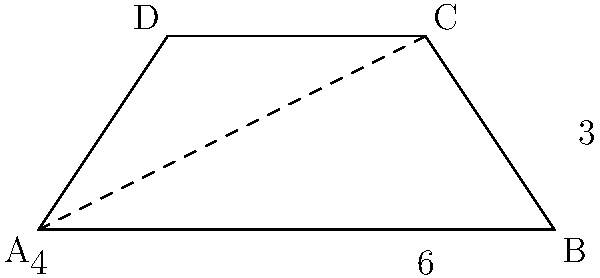A garden plot is shaped like a trapezoid. The parallel sides measure 4 meters and 6 meters, and the height of the trapezoid is 3 meters. What is the area of this garden plot in square meters? To find the area of a trapezoid, we can use the formula:

$$ \text{Area} = \frac{1}{2}(a+b)h $$

Where:
$a$ and $b$ are the lengths of the parallel sides
$h$ is the height of the trapezoid

Let's plug in our values:

$a = 4$ meters (shorter parallel side)
$b = 6$ meters (longer parallel side)
$h = 3$ meters (height)

Now, let's calculate:

$$ \text{Area} = \frac{1}{2}(4+6) \times 3 $$
$$ = \frac{1}{2}(10) \times 3 $$
$$ = 5 \times 3 $$
$$ = 15 $$

Therefore, the area of the garden plot is 15 square meters.
Answer: 15 square meters 